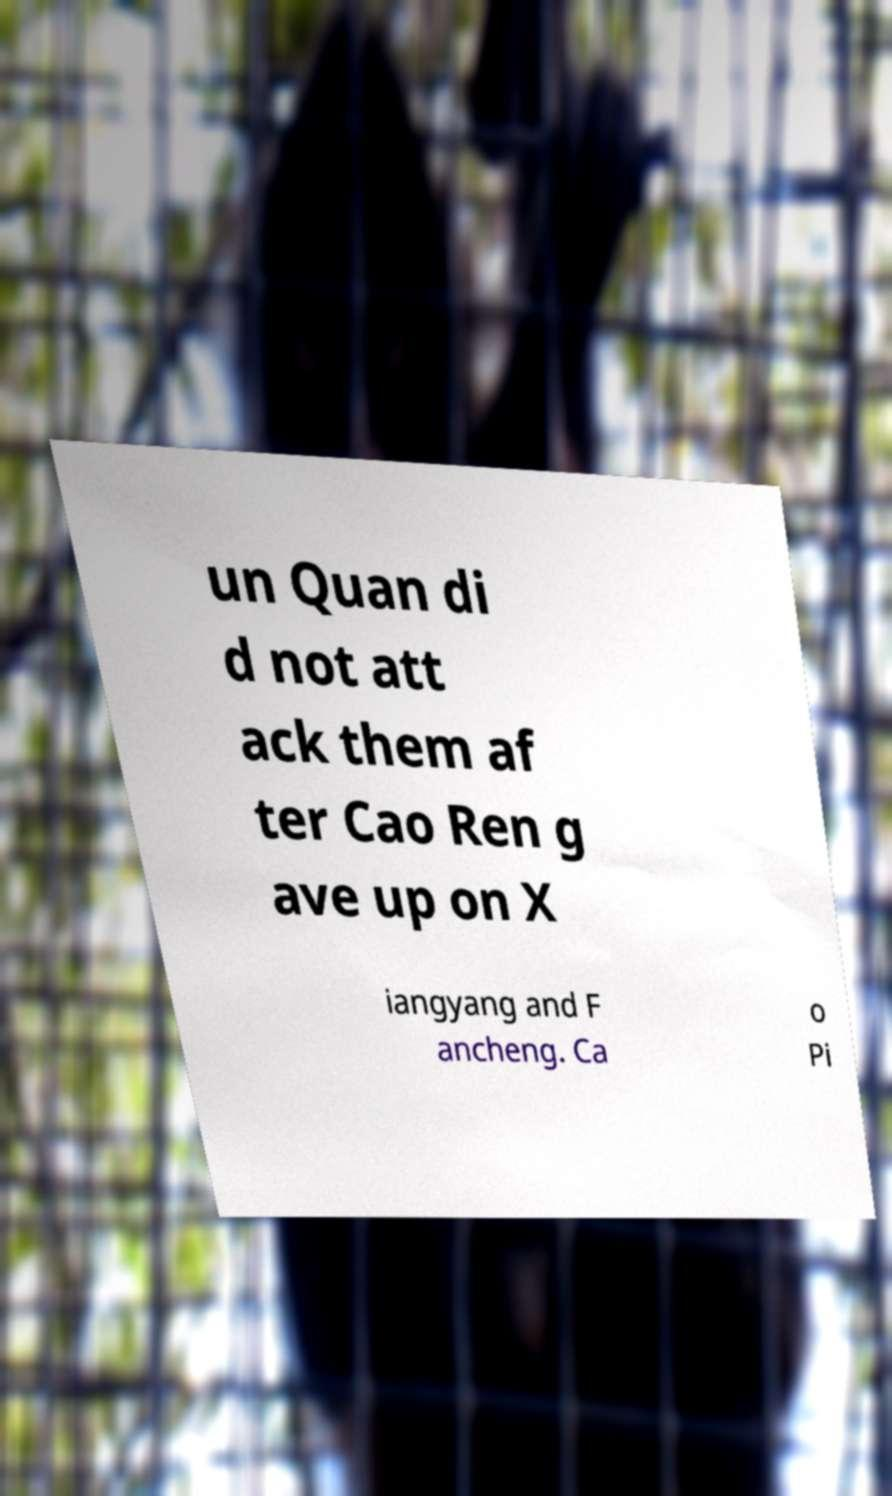Can you read and provide the text displayed in the image?This photo seems to have some interesting text. Can you extract and type it out for me? un Quan di d not att ack them af ter Cao Ren g ave up on X iangyang and F ancheng. Ca o Pi 